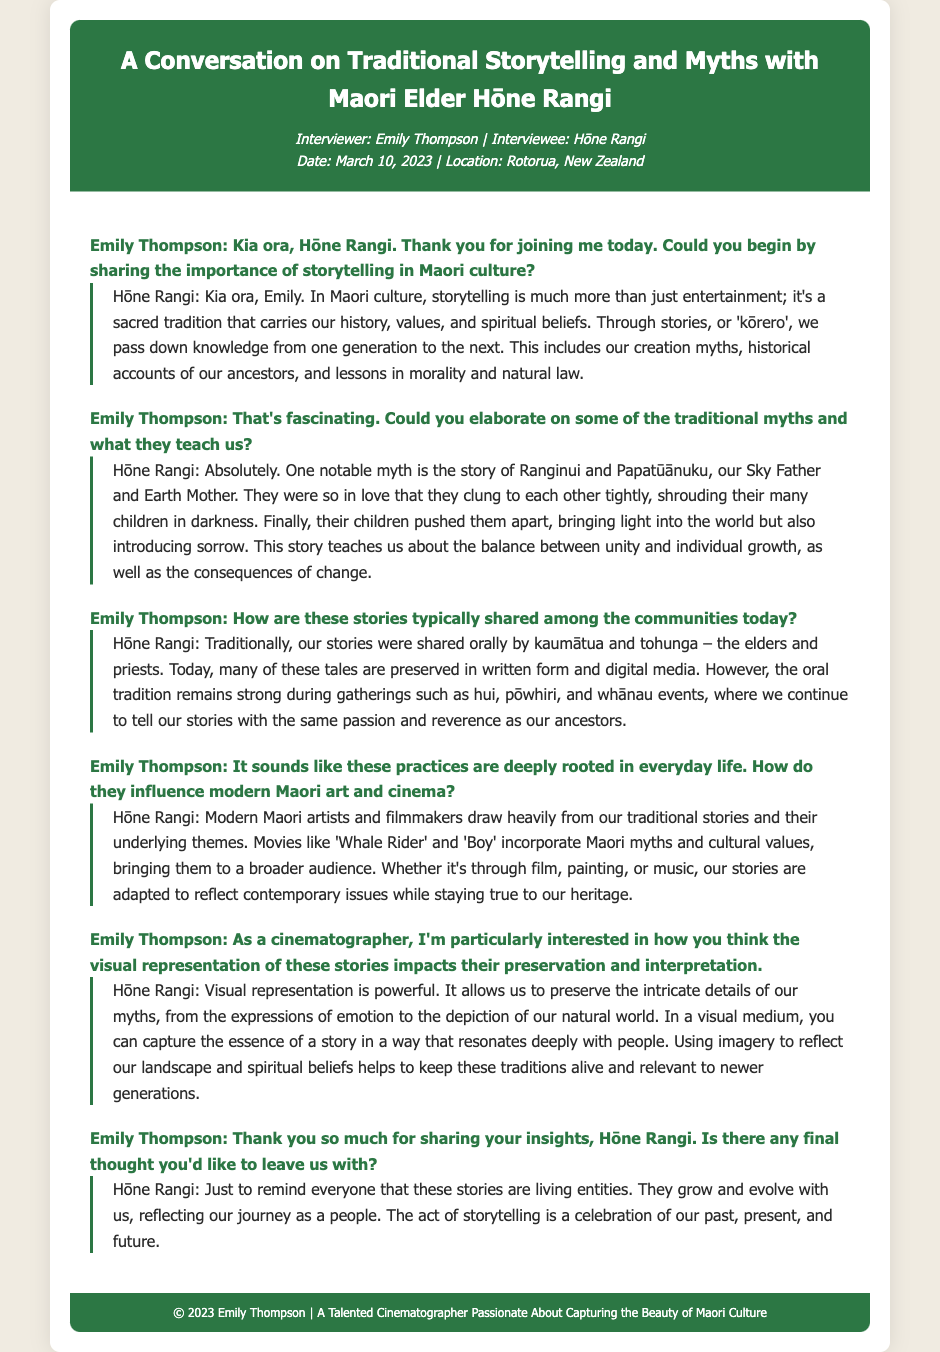What is the name of the interviewer? The name of the interviewer is mentioned at the beginning of the document.
Answer: Emily Thompson What is the date of the interview? The date of the interview is indicated in the meta section.
Answer: March 10, 2023 Who is the interviewee? The name of the person being interviewed is listed in the document's header.
Answer: Hōne Rangi What is the cultural significance of storytelling in Maori culture? The document describes storytelling as carrying history, values, and spiritual beliefs in Maori culture.
Answer: Sacred tradition What are some modern Maori films mentioned? The response includes specific examples of films influenced by Maori traditional stories.
Answer: Whale Rider and Boy What does the myth of Ranginui and Papatūānuku teach? The discussion explains the themes conveyed in this myth, specifically related to unity and change.
Answer: Balance between unity and individual growth Where are Maori stories typically shared today? The answer refers to current venues for storytelling in the community.
Answer: Hui, pōwhiri, whānau events What does Hōne Rangi suggest about visual representation in storytelling? The interviewee emphasizes the importance of visuals in preserving and interpreting stories.
Answer: Powerful What is a final thought shared by Hōne Rangi? The conclusion of the interview includes a significant statement about the nature of stories.
Answer: Living entities 